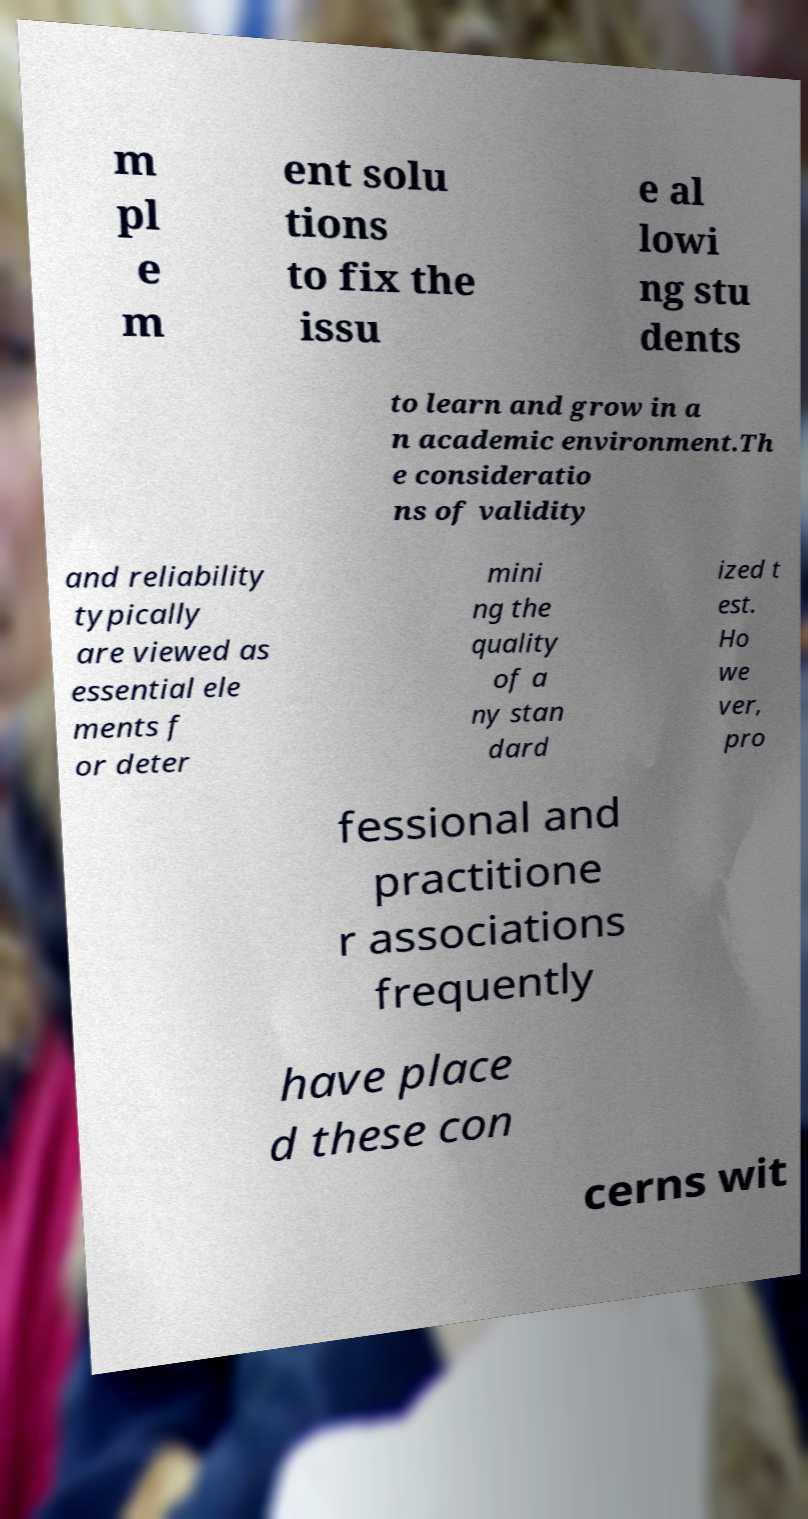Could you extract and type out the text from this image? m pl e m ent solu tions to fix the issu e al lowi ng stu dents to learn and grow in a n academic environment.Th e consideratio ns of validity and reliability typically are viewed as essential ele ments f or deter mini ng the quality of a ny stan dard ized t est. Ho we ver, pro fessional and practitione r associations frequently have place d these con cerns wit 